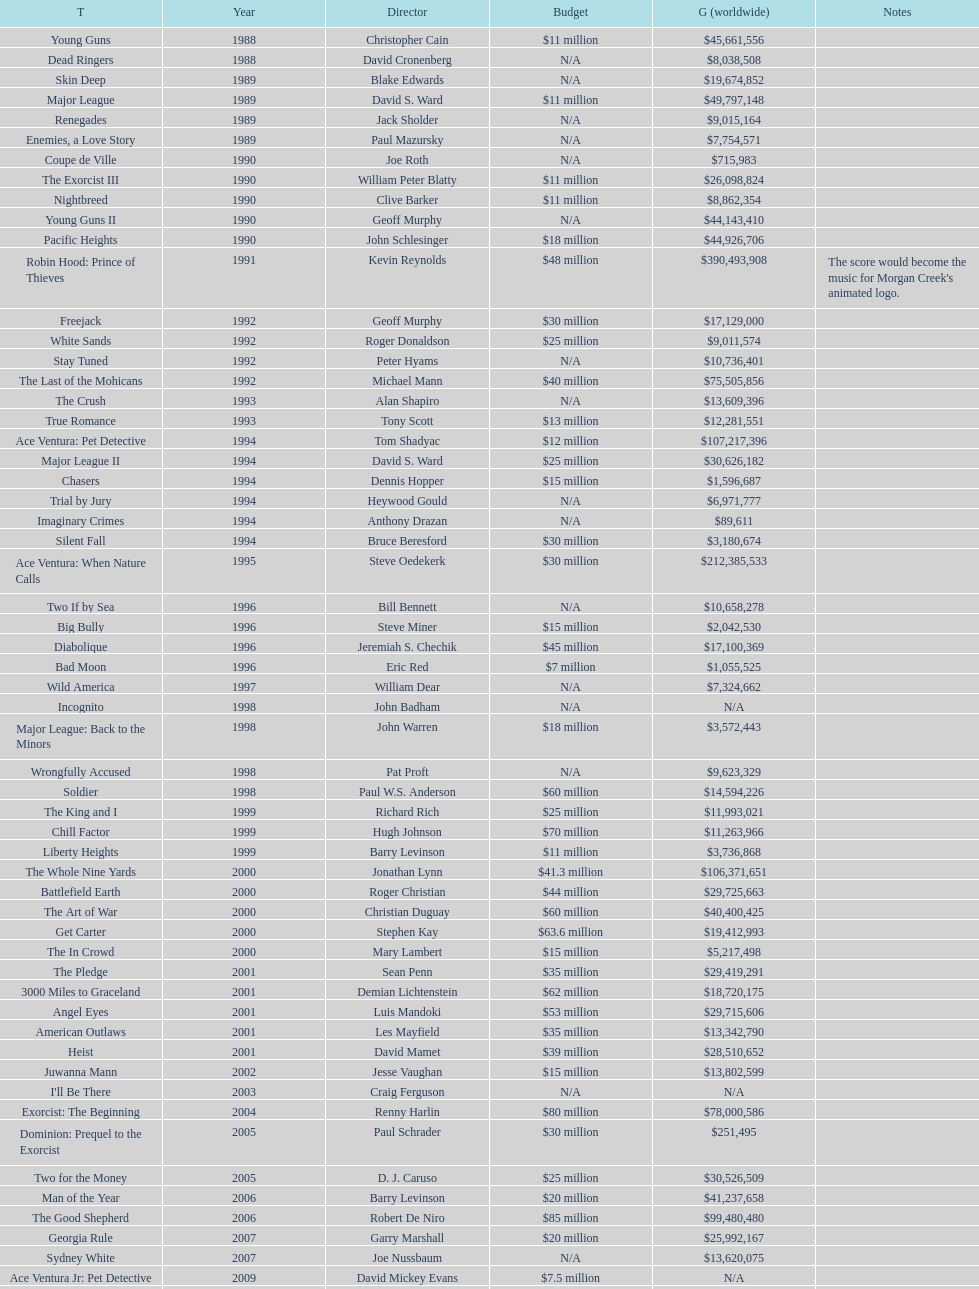Did true romance generate higher or lower revenue compared to diabolique? Less. 